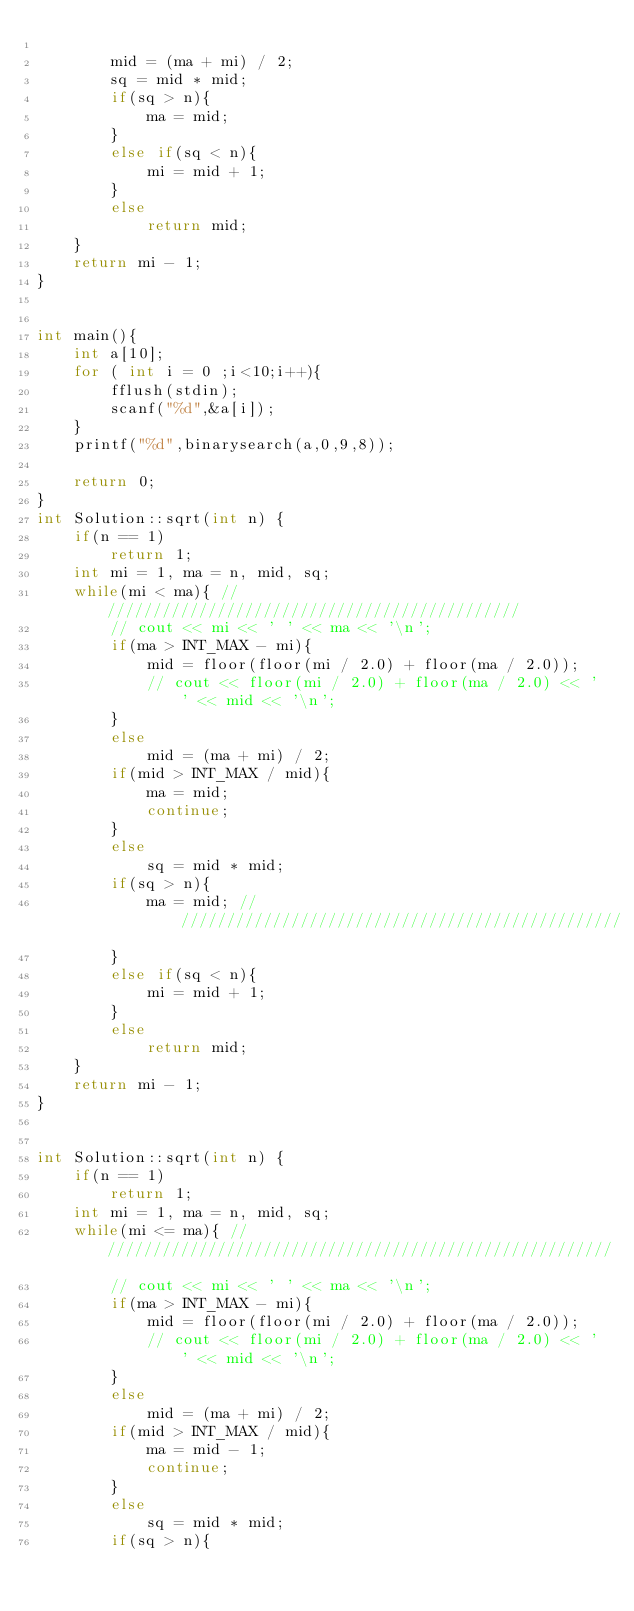<code> <loc_0><loc_0><loc_500><loc_500><_C_>        
        mid = (ma + mi) / 2;
        sq = mid * mid;
        if(sq > n){
            ma = mid;
        }
        else if(sq < n){
            mi = mid + 1;
        }
        else 
            return mid;
    }
    return mi - 1;
}


int main(){
	int a[10];
	for ( int i = 0 ;i<10;i++){
		fflush(stdin);
		scanf("%d",&a[i]);
	}
	printf("%d",binarysearch(a,0,9,8));
	
	return 0;
}
int Solution::sqrt(int n) {
    if(n == 1)
        return 1;
    int mi = 1, ma = n, mid, sq;
    while(mi < ma){ ///////////////////////////////////////////////
        // cout << mi << ' ' << ma << '\n';
        if(ma > INT_MAX - mi){
            mid = floor(floor(mi / 2.0) + floor(ma / 2.0));
            // cout << floor(mi / 2.0) + floor(ma / 2.0) << ' ' << mid << '\n';
        }
        else
            mid = (ma + mi) / 2;
        if(mid > INT_MAX / mid){
            ma = mid;
            continue;
        }
        else
            sq = mid * mid;
        if(sq > n){
            ma = mid; //////////////////////////////////////////////////
        }
        else if(sq < n){
            mi = mid + 1;
        }
        else 
            return mid;
    }
    return mi - 1;
}


int Solution::sqrt(int n) {
    if(n == 1)
        return 1;
    int mi = 1, ma = n, mid, sq;
    while(mi <= ma){ /////////////////////////////////////////////////////////
        // cout << mi << ' ' << ma << '\n';
        if(ma > INT_MAX - mi){
            mid = floor(floor(mi / 2.0) + floor(ma / 2.0));
            // cout << floor(mi / 2.0) + floor(ma / 2.0) << ' ' << mid << '\n';
        }
        else
            mid = (ma + mi) / 2;
        if(mid > INT_MAX / mid){
            ma = mid - 1;
            continue;
        }
        else
            sq = mid * mid;
        if(sq > n){</code> 